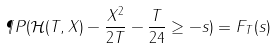<formula> <loc_0><loc_0><loc_500><loc_500>\P P ( \mathcal { H } ( T , X ) - \frac { X ^ { 2 } } { 2 T } - \frac { T } { 2 4 } \geq - s ) = F _ { T } ( s )</formula> 